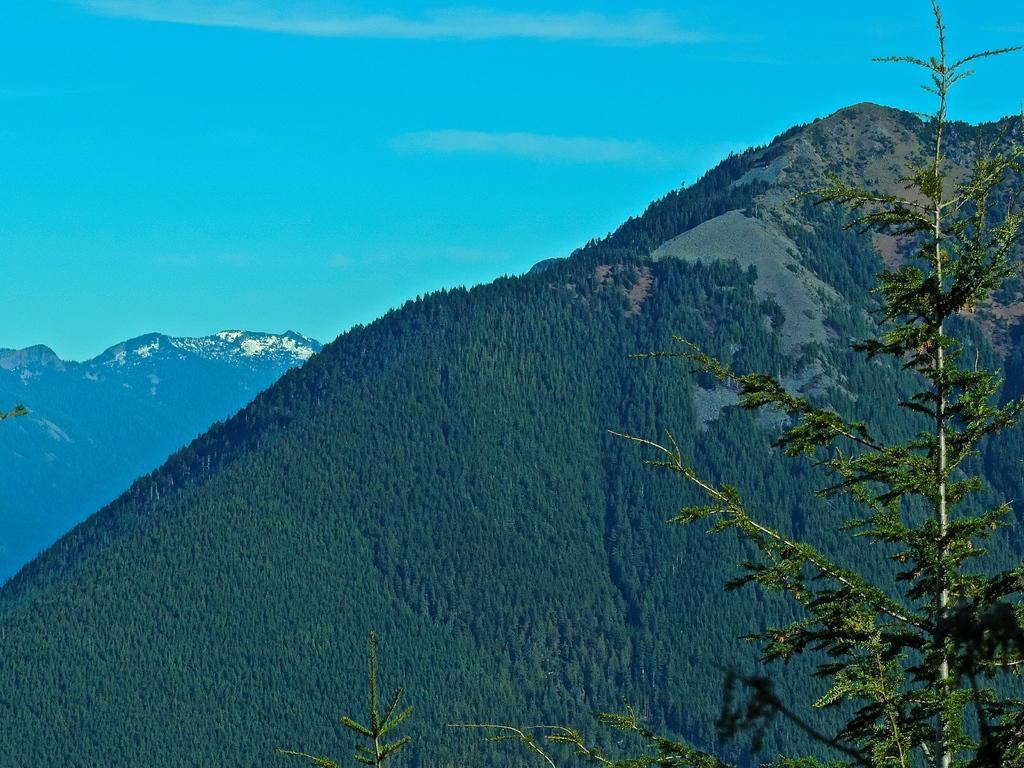Could you give a brief overview of what you see in this image? Here in this picture we can see mountains that are covered with grass, plants and trees and in the far some mountains are covered with snow and we can see clouds in the sky and in the front we can see a tree present. 